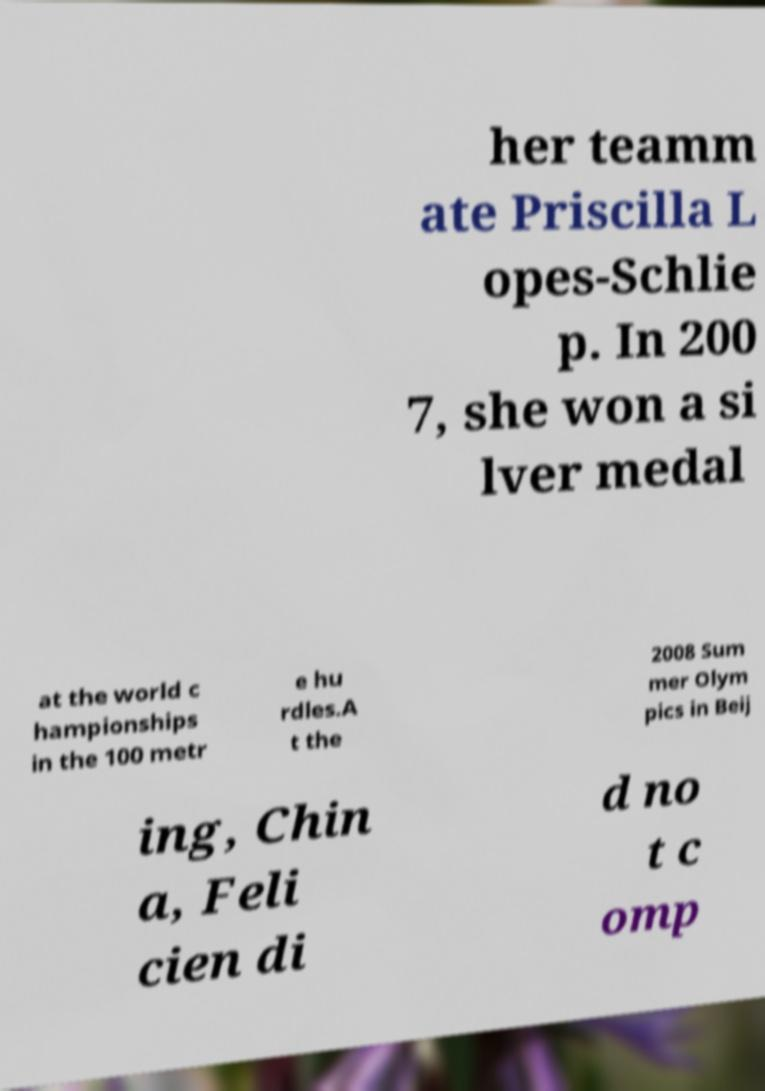What messages or text are displayed in this image? I need them in a readable, typed format. her teamm ate Priscilla L opes-Schlie p. In 200 7, she won a si lver medal at the world c hampionships in the 100 metr e hu rdles.A t the 2008 Sum mer Olym pics in Beij ing, Chin a, Feli cien di d no t c omp 